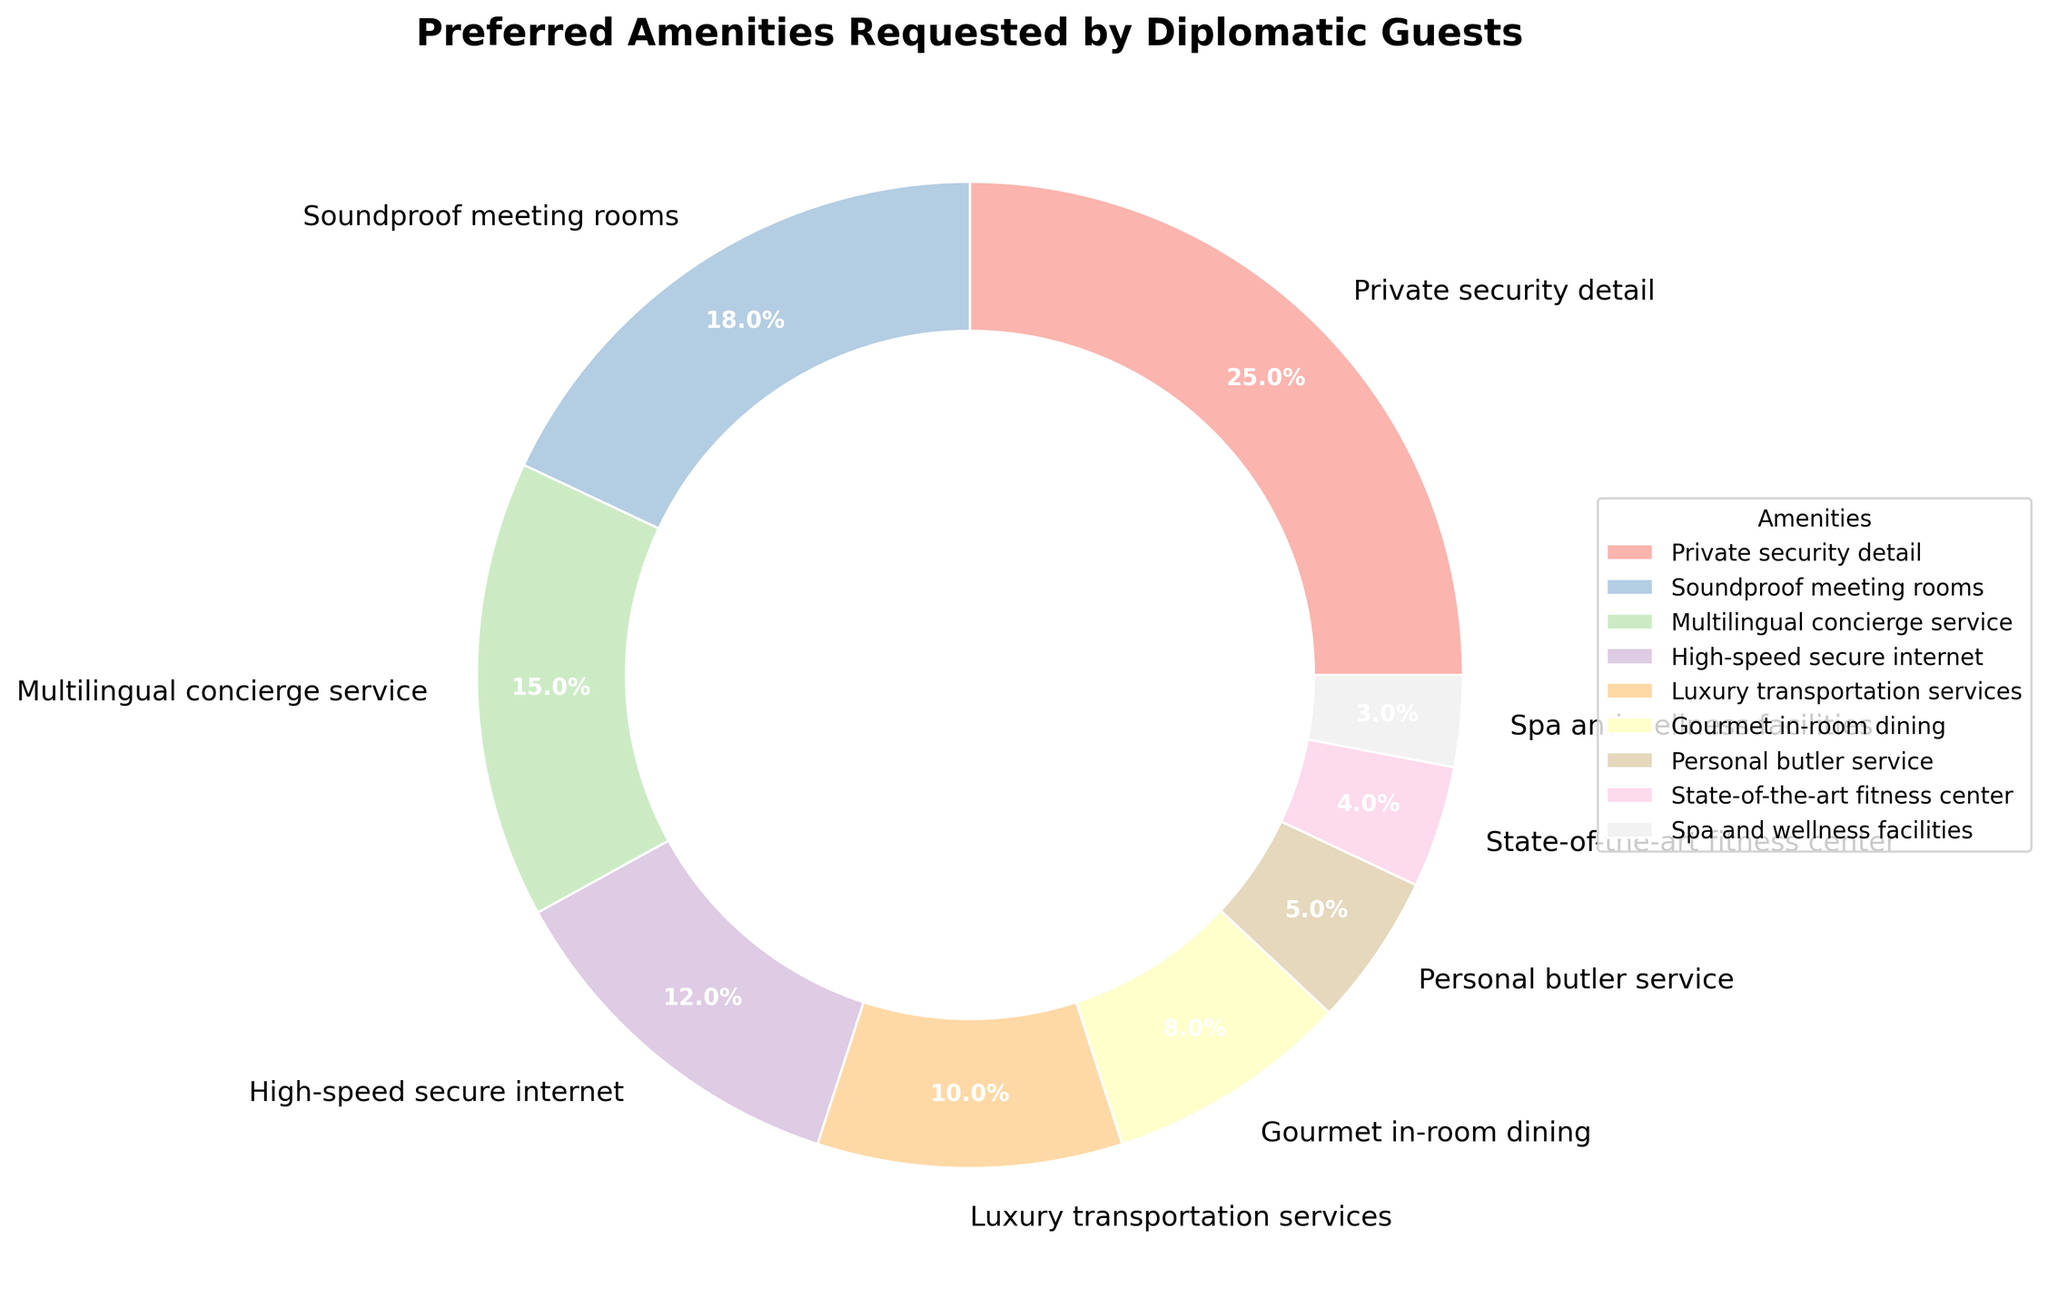What percentage of guests requested Private security detail? The pie chart indicates that Private security detail is requested by 25% of the guests.
Answer: 25% Which amenity has the second highest preference among diplomatic guests? From the chart, Soundproof meeting rooms hold the second highest preference with 18%.
Answer: Soundproof meeting rooms What is the total percentage of guests who requested Multilingual concierge service and High-speed secure internet combined? Adding the percentages for these two amenities: 15% (Multilingual concierge service) + 12% (High-speed secure internet) = 27%.
Answer: 27% Compare the preference for Luxury transportation services and Gourmet in-room dining. Which one is more preferred and by how much? Luxury transportation services have a 10% preference, while Gourmet in-room dining has an 8% preference. The difference is 10% - 8% = 2%.
Answer: Luxury transportation services by 2% What is the least preferred amenity according to the chart? The least preferred amenity is Spa and wellness facilities with 3%.
Answer: Spa and wellness facilities What is the combined percentage for amenities related to personal services (Gourmet in-room dining, Personal butler service, and Spa and wellness facilities)? Summing these up: 8% (Gourmet in-room dining) + 5% (Personal butler service) + 3% (Spa and wellness facilities) = 16%.
Answer: 16% Compare the preference for the top preferred amenity with the least preferred ones. What is the difference in their percentages? The top preferred amenity is Private security detail at 25% and the least preferred is Spa and wellness facilities at 3%. The difference is 25% - 3% = 22%.
Answer: 22% How does the preference for High-speed secure internet compare to Luxury transportation services? The chart shows High-speed secure internet is preferred by 12% while Luxury transportation services are preferred by 10%, making High-speed secure internet 2% more preferred.
Answer: High-speed secure internet by 2% What percentage of guests requested amenities related to communication (Multilingual concierge service and High-speed secure internet)? Adding these percentages: 15% (Multilingual concierge service) + 12% (High-speed secure internet) = 27%.
Answer: 27% How many amenities have a preference percentage below 10%? From the chart, four amenities have a preference below 10%: Gourmet in-room dining (8%), Personal butler service (5%), State-of-the-art fitness center (4%), and Spa and wellness facilities (3%).
Answer: Four 